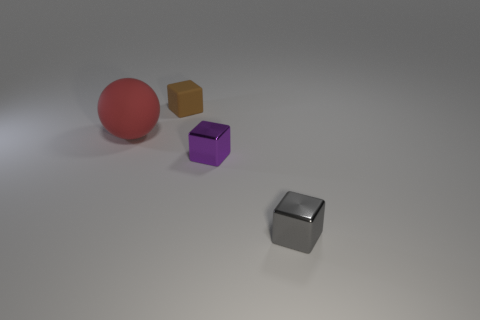Add 2 large red matte objects. How many objects exist? 6 Subtract all cubes. How many objects are left? 1 Subtract 0 gray cylinders. How many objects are left? 4 Subtract all green shiny cubes. Subtract all tiny brown cubes. How many objects are left? 3 Add 4 small gray metallic objects. How many small gray metallic objects are left? 5 Add 4 large red matte balls. How many large red matte balls exist? 5 